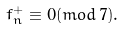<formula> <loc_0><loc_0><loc_500><loc_500>f _ { n } ^ { + } \equiv 0 ( m o d \, 7 ) .</formula> 